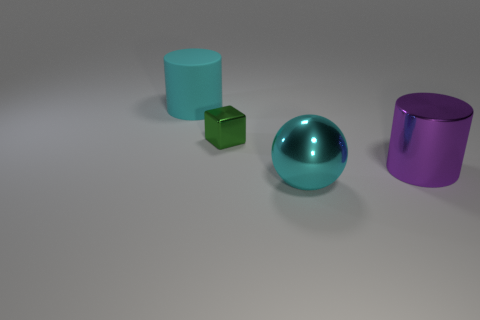Is there any other thing that is the same size as the green metal thing?
Offer a very short reply. No. There is a cyan object that is to the right of the large cylinder to the left of the cylinder on the right side of the cyan rubber thing; what is its size?
Your answer should be very brief. Large. How many objects are either large metallic things that are to the left of the big metal cylinder or cyan objects in front of the big cyan matte thing?
Provide a short and direct response. 1. What shape is the green metal object?
Ensure brevity in your answer.  Cube. What number of other things are there of the same material as the sphere
Your answer should be very brief. 2. There is a metallic thing that is the same shape as the big rubber thing; what is its size?
Ensure brevity in your answer.  Large. What is the cylinder that is left of the large metallic object that is in front of the thing on the right side of the large cyan metal sphere made of?
Your response must be concise. Rubber. Is there a tiny metallic object?
Keep it short and to the point. Yes. There is a cube; is it the same color as the thing that is in front of the purple metallic object?
Ensure brevity in your answer.  No. What color is the small metallic thing?
Ensure brevity in your answer.  Green. 